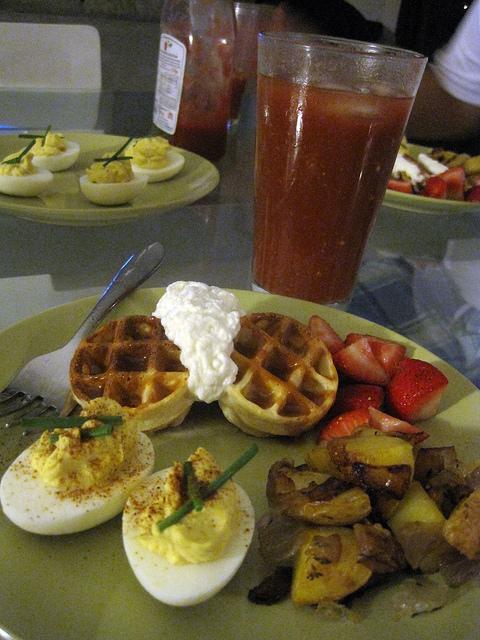How many varieties of donuts are there?
Give a very brief answer. 0. 